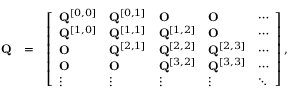Convert formula to latex. <formula><loc_0><loc_0><loc_500><loc_500>\begin{array} { r l r } { Q } & { = } & { \left [ \begin{array} { l l l l l } { { Q } ^ { [ 0 , 0 ] } } & { { Q } ^ { [ 0 , 1 ] } } & { O } & { O } & { \cdots } \\ { { Q } ^ { [ 1 , 0 ] } } & { { Q } ^ { [ 1 , 1 ] } } & { { Q } ^ { [ 1 , 2 ] } } & { O } & { \cdots } \\ { O } & { { Q } ^ { [ 2 , 1 ] } } & { { Q } ^ { [ 2 , 2 ] } } & { { Q } ^ { [ 2 , 3 ] } } & { \cdots } \\ { O } & { O } & { { Q } ^ { [ 3 , 2 ] } } & { { Q } ^ { [ 3 , 3 ] } } & { \cdots } \\ { \vdots } & { \vdots } & { \vdots } & { \vdots } & { \ddots } \end{array} \right ] , } \end{array}</formula> 